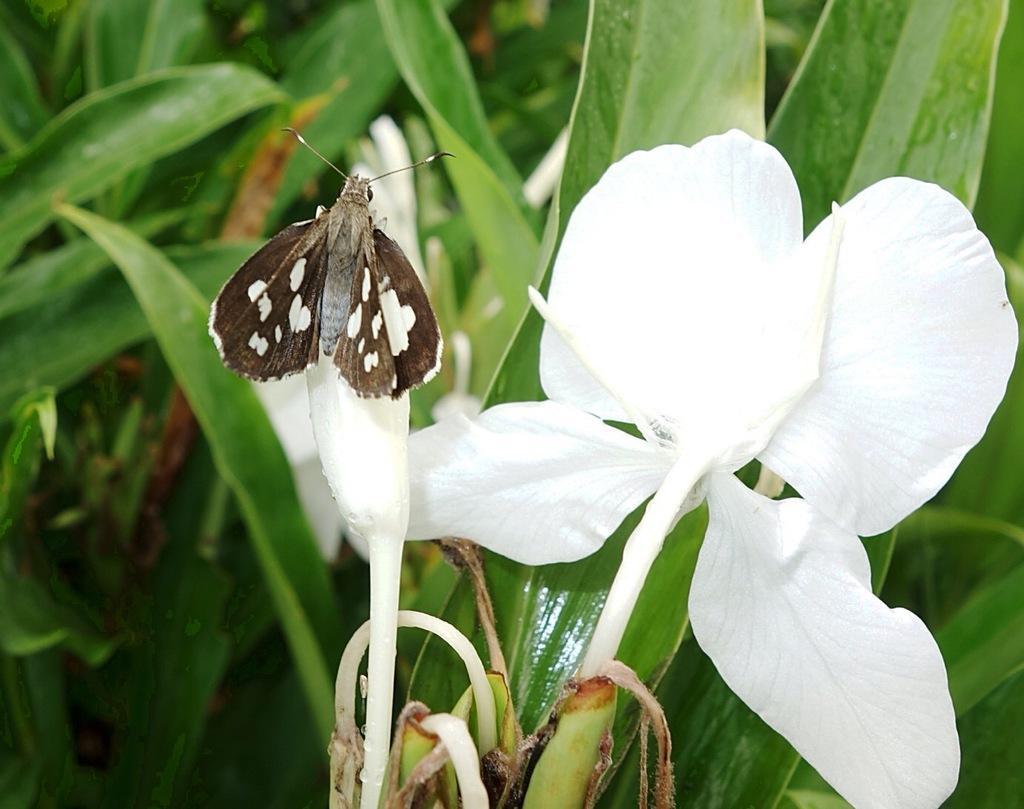Describe this image in one or two sentences. There is an insect on the bud. Here we can see a flower and plants. 